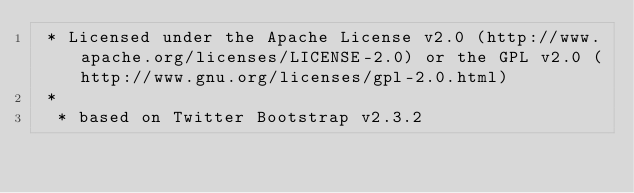Convert code to text. <code><loc_0><loc_0><loc_500><loc_500><_CSS_> * Licensed under the Apache License v2.0 (http://www.apache.org/licenses/LICENSE-2.0) or the GPL v2.0 (http://www.gnu.org/licenses/gpl-2.0.html)
 *
  * based on Twitter Bootstrap v2.3.2</code> 